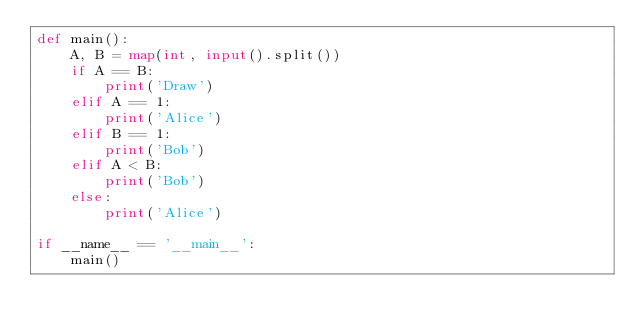Convert code to text. <code><loc_0><loc_0><loc_500><loc_500><_Python_>def main():
    A, B = map(int, input().split())
    if A == B:
        print('Draw')
    elif A == 1:
        print('Alice')
    elif B == 1:
        print('Bob')
    elif A < B:
        print('Bob')
    else:
        print('Alice')

if __name__ == '__main__':
    main()
</code> 